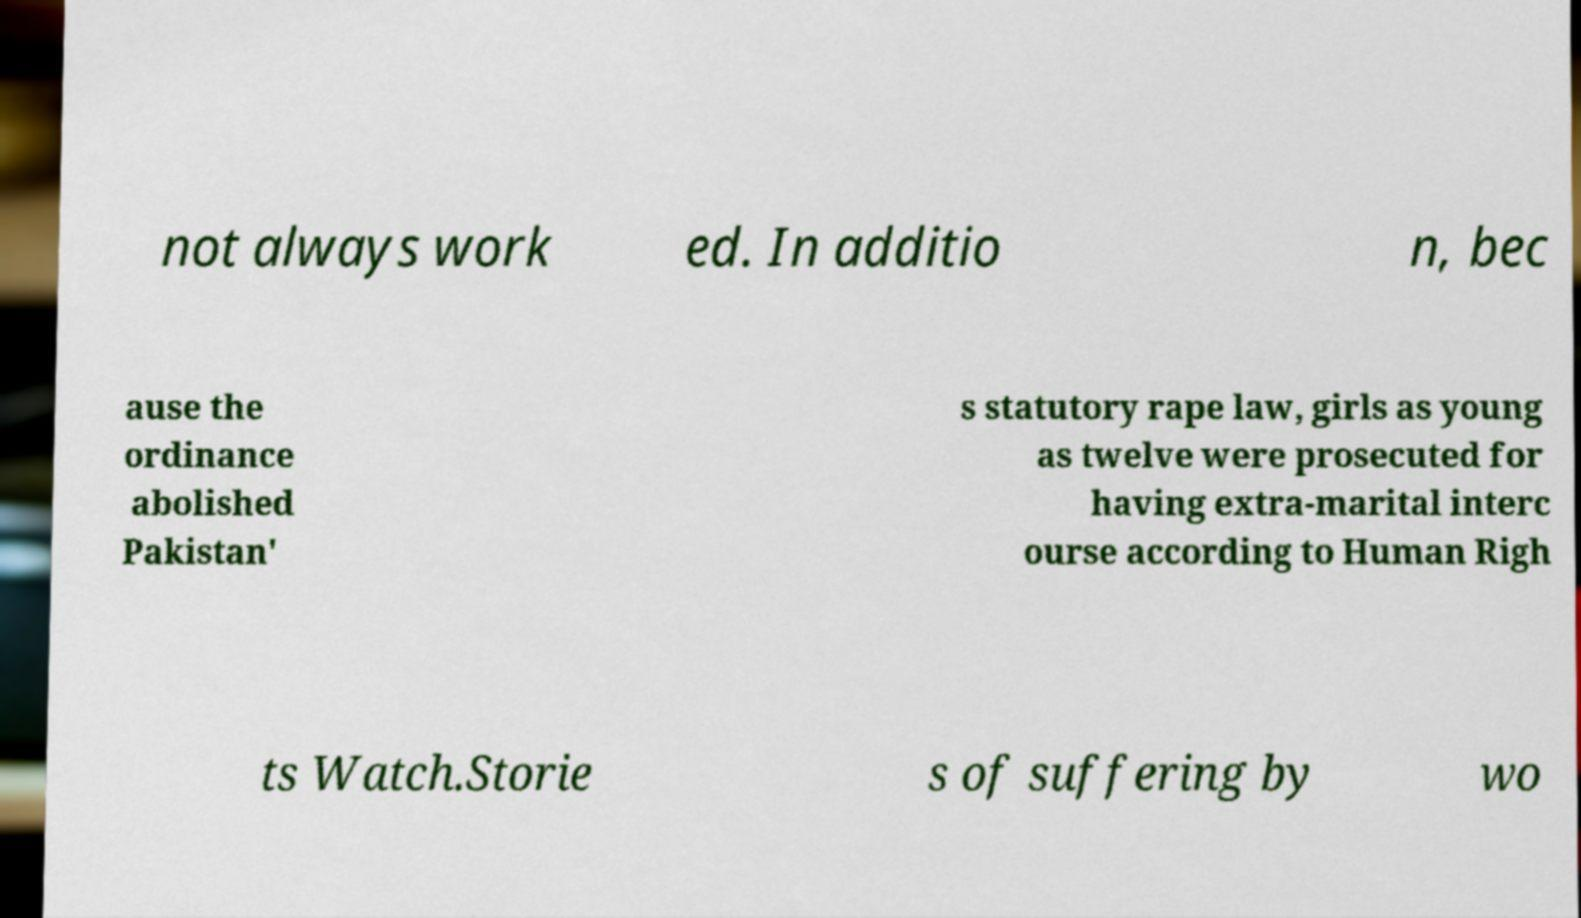What messages or text are displayed in this image? I need them in a readable, typed format. not always work ed. In additio n, bec ause the ordinance abolished Pakistan' s statutory rape law, girls as young as twelve were prosecuted for having extra-marital interc ourse according to Human Righ ts Watch.Storie s of suffering by wo 